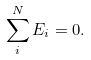<formula> <loc_0><loc_0><loc_500><loc_500>\sum _ { i } ^ { N } E _ { i } = 0 .</formula> 